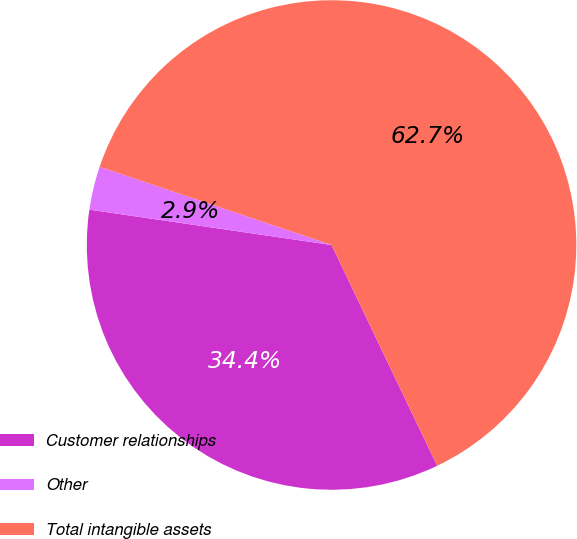Convert chart. <chart><loc_0><loc_0><loc_500><loc_500><pie_chart><fcel>Customer relationships<fcel>Other<fcel>Total intangible assets<nl><fcel>34.41%<fcel>2.87%<fcel>62.73%<nl></chart> 